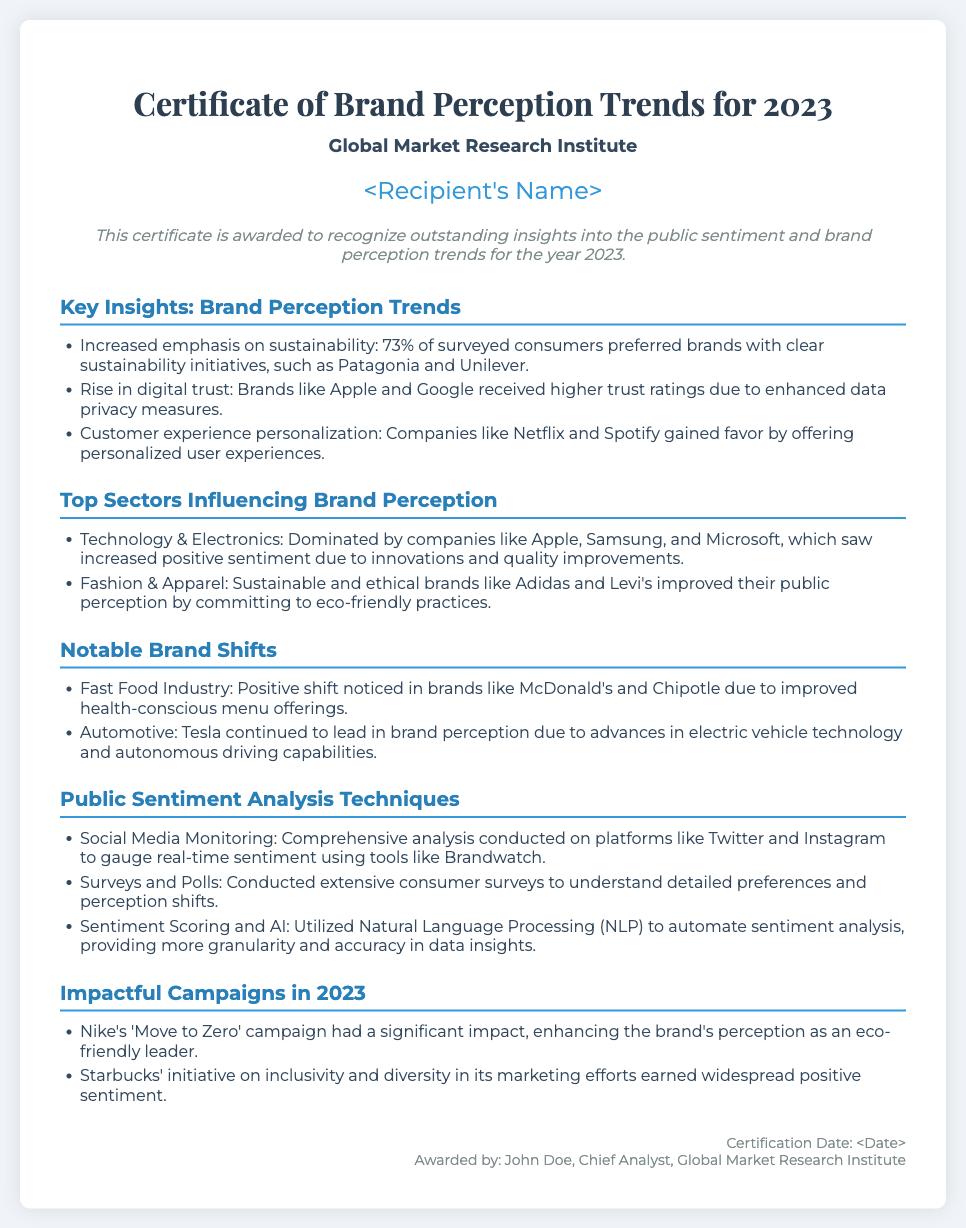What is the title of the certificate? The document title is prominently stated at the top as the "Certificate of Brand Perception Trends for 2023."
Answer: Certificate of Brand Perception Trends for 2023 Who awarded the certificate? The awarding body is mentioned in the header section as "Global Market Research Institute."
Answer: Global Market Research Institute What percentage of surveyed consumers preferred brands with sustainability initiatives? The document states that "73% of surveyed consumers" preferred such brands.
Answer: 73% What is one method used for public sentiment analysis? The document lists "Social Media Monitoring" as one of the methods used in public sentiment analysis.
Answer: Social Media Monitoring Name one brand that saw a positive shift in the fast food industry. The document mentions "McDonald's" as one of the brands experiencing a positive shift.
Answer: McDonald's Which campaign enhanced Nike's perception as an eco-friendly leader? The document refers to Nike's campaign as "'Move to Zero' campaign."
Answer: Move to Zero What brand leads in automotive perception due to advancements in EV technology? Tesla is identified in the document as the leader in brand perception in the automotive sector.
Answer: Tesla What type of analysis is mentioned using Natural Language Processing? The document describes the use of "Sentiment Scoring and AI" as part of the analysis techniques.
Answer: Sentiment Scoring and AI 